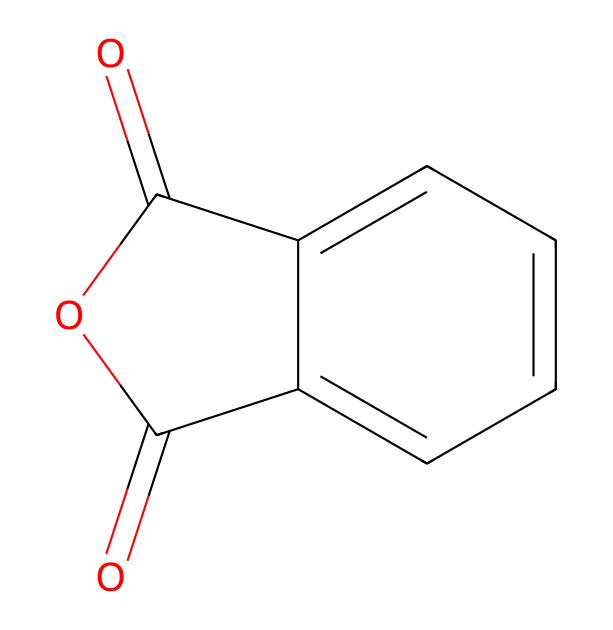What is the molecular formula of phthalic anhydride? The molecular formula can be determined by counting the number and type of each atom in the structure. The structure contains 8 carbons, 4 oxygens, and 4 hydrogens. Thus, the formula is C8H4O3.
Answer: C8H4O3 How many carbon atoms are in phthalic anhydride? By examining the structure, we can identify 8 carbon atoms present in the chemical. Counting them gives a total of 8.
Answer: 8 What type of functional groups are present in phthalic anhydride? The structure shows an anhydride functional group (two carbonyls connected by an oxygen) and a benzene ring, which indicates aromatic character. Hence, it contains an anhydride and an aromatic group.
Answer: anhydride, aromatic What is the main application of phthalic anhydride? Phthalic anhydride is primarily used as an intermediate for producing plastics, dyes, and pigments, commonly utilized in inks and coatings.
Answer: plastics, dyes How many double bonds are present in the structure of phthalic anhydride? Looking at the structure, there are two carbonyl double bonds (C=O) and an additional double bond in the aromatic ring (C=C). When counted, this totals three double bonds.
Answer: 3 Which part of the structure indicates that phthalic anhydride is an anhydride? The presence of the cyclic structure with two carbonyls next to each other linked by an oxygen indicates that it is an anhydride, which is a characteristic feature of such compounds.
Answer: cyclic structure with two carbonyls What is the state of phthalic anhydride at room temperature? Phthalic anhydride is commonly found in a solid state at room temperature as it has a melting point around 131 °C. Hence, at room temperature, it will not be in liquid form.
Answer: solid 